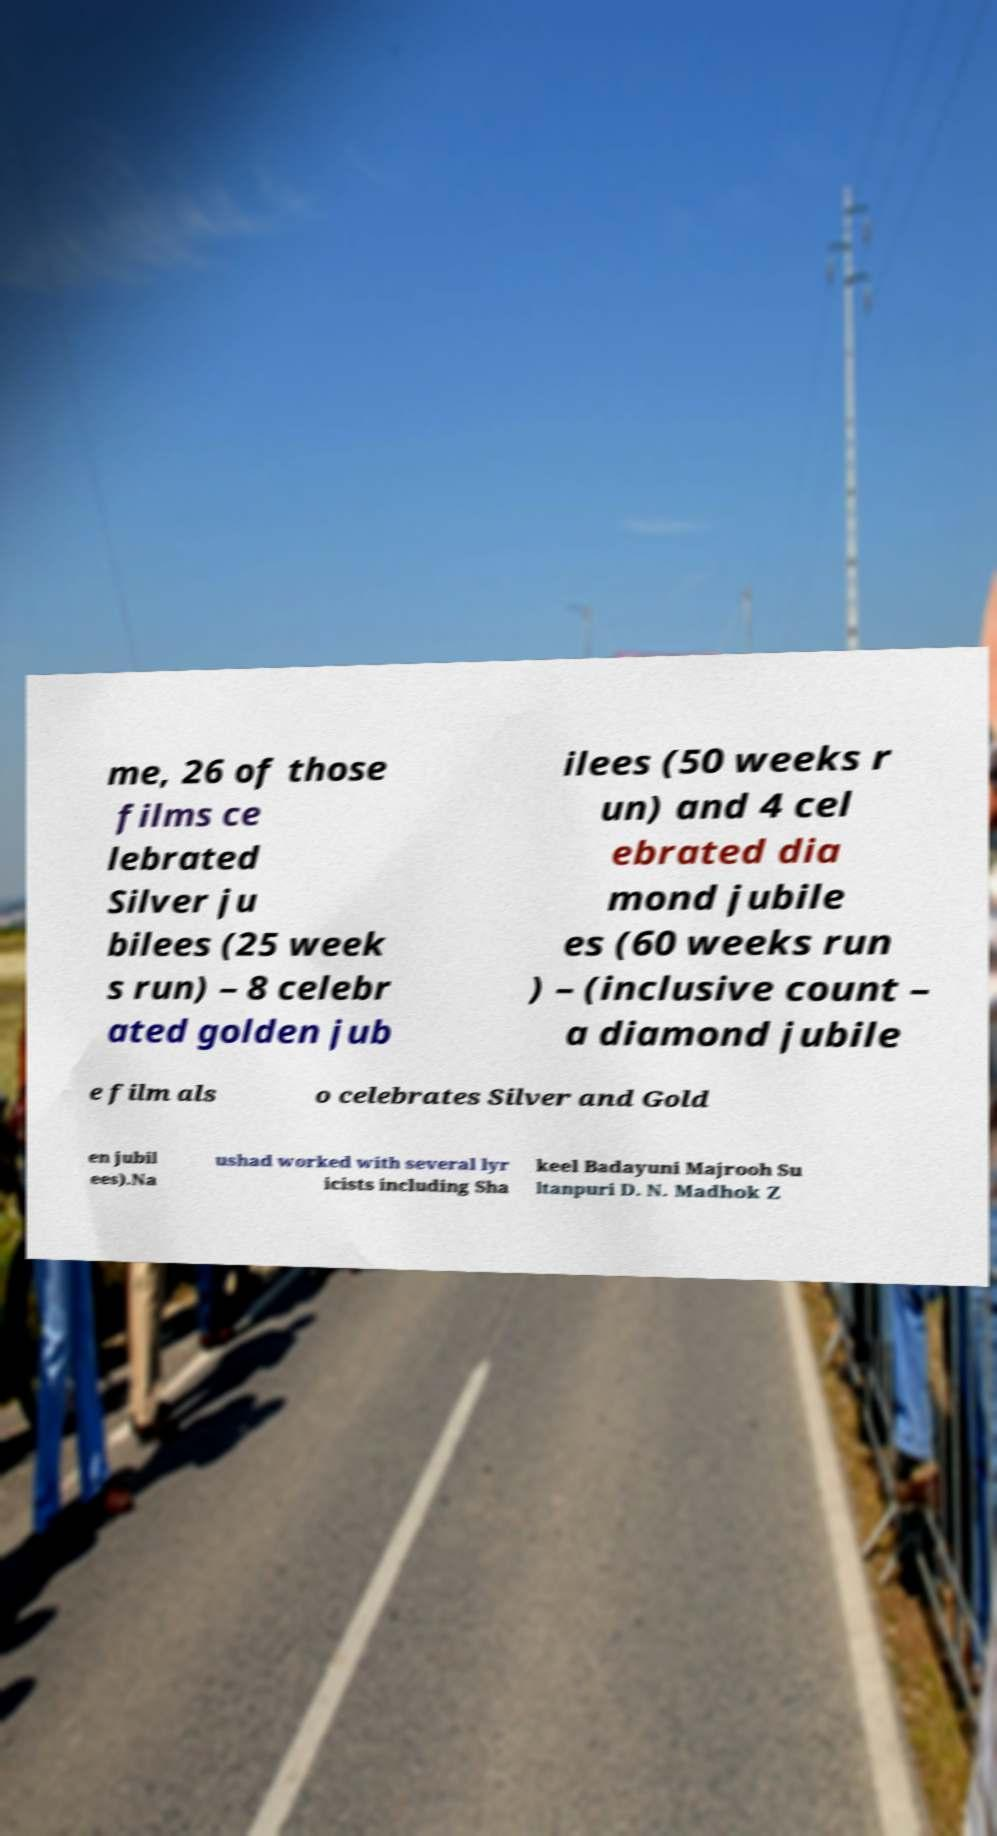Can you read and provide the text displayed in the image?This photo seems to have some interesting text. Can you extract and type it out for me? me, 26 of those films ce lebrated Silver ju bilees (25 week s run) – 8 celebr ated golden jub ilees (50 weeks r un) and 4 cel ebrated dia mond jubile es (60 weeks run ) – (inclusive count – a diamond jubile e film als o celebrates Silver and Gold en jubil ees).Na ushad worked with several lyr icists including Sha keel Badayuni Majrooh Su ltanpuri D. N. Madhok Z 